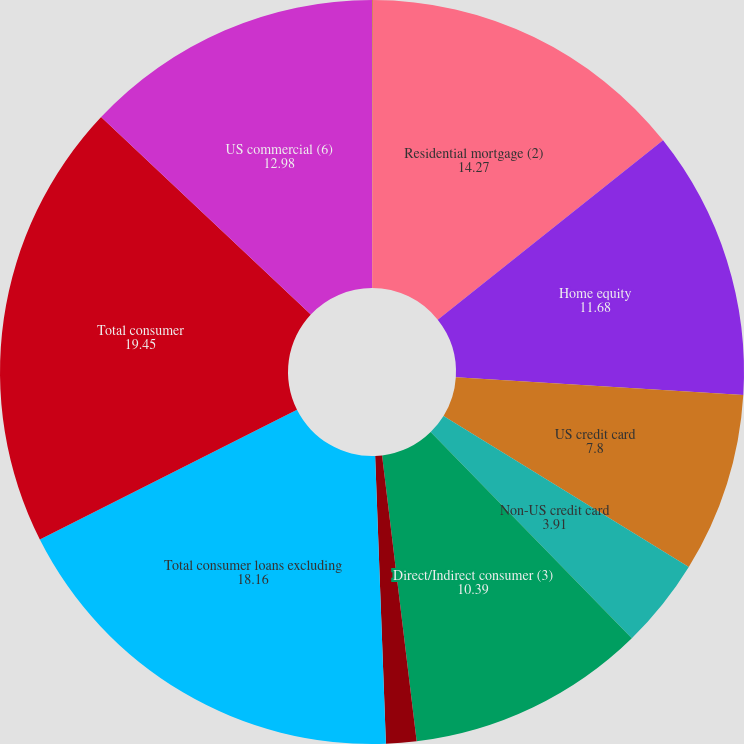Convert chart to OTSL. <chart><loc_0><loc_0><loc_500><loc_500><pie_chart><fcel>(Dollars in millions)<fcel>Residential mortgage (2)<fcel>Home equity<fcel>US credit card<fcel>Non-US credit card<fcel>Direct/Indirect consumer (3)<fcel>Other consumer (4)<fcel>Total consumer loans excluding<fcel>Total consumer<fcel>US commercial (6)<nl><fcel>0.03%<fcel>14.27%<fcel>11.68%<fcel>7.8%<fcel>3.91%<fcel>10.39%<fcel>1.32%<fcel>18.16%<fcel>19.45%<fcel>12.98%<nl></chart> 